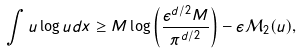<formula> <loc_0><loc_0><loc_500><loc_500>\int u \log u d x \geq M \log \left ( \frac { \epsilon ^ { d / 2 } M } { \pi ^ { d / 2 } } \right ) - \epsilon \mathcal { M } _ { 2 } ( u ) ,</formula> 